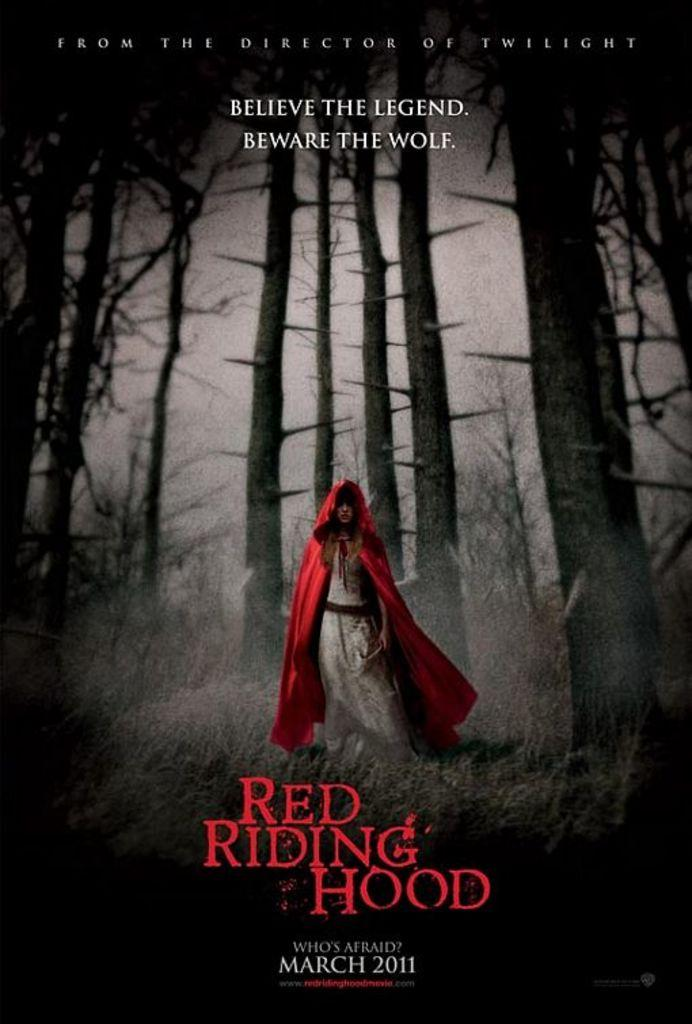<image>
Offer a succinct explanation of the picture presented. A Red Riding Hood poster that is on the ground 